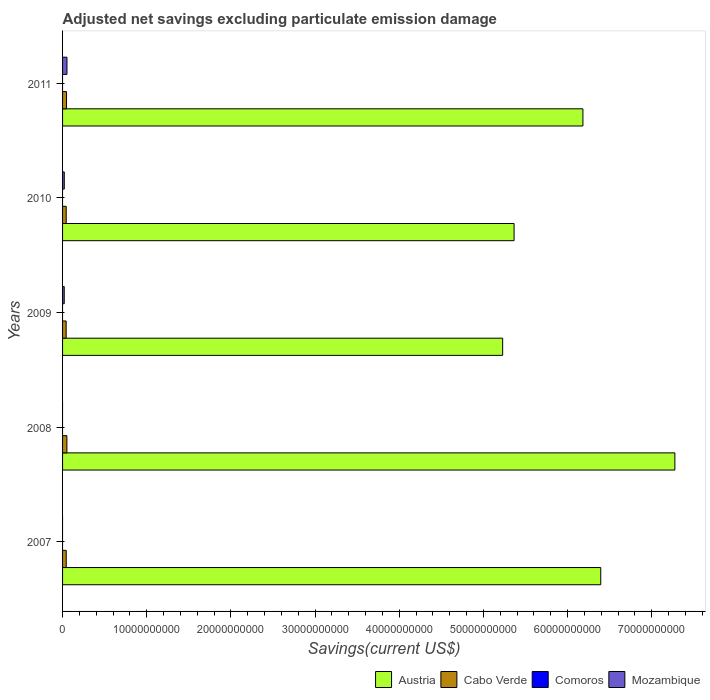How many different coloured bars are there?
Provide a succinct answer. 3. How many groups of bars are there?
Ensure brevity in your answer.  5. How many bars are there on the 4th tick from the top?
Your answer should be compact. 2. How many bars are there on the 1st tick from the bottom?
Provide a succinct answer. 2. What is the label of the 5th group of bars from the top?
Offer a very short reply. 2007. In how many cases, is the number of bars for a given year not equal to the number of legend labels?
Keep it short and to the point. 5. What is the adjusted net savings in Austria in 2007?
Keep it short and to the point. 6.39e+1. Across all years, what is the maximum adjusted net savings in Austria?
Make the answer very short. 7.27e+1. Across all years, what is the minimum adjusted net savings in Austria?
Your answer should be compact. 5.23e+1. What is the difference between the adjusted net savings in Cabo Verde in 2007 and that in 2011?
Offer a very short reply. -3.84e+07. What is the difference between the adjusted net savings in Mozambique in 2010 and the adjusted net savings in Austria in 2007?
Ensure brevity in your answer.  -6.37e+1. What is the average adjusted net savings in Comoros per year?
Give a very brief answer. 0. In the year 2008, what is the difference between the adjusted net savings in Cabo Verde and adjusted net savings in Austria?
Keep it short and to the point. -7.22e+1. What is the ratio of the adjusted net savings in Austria in 2008 to that in 2010?
Your response must be concise. 1.36. Is the adjusted net savings in Austria in 2008 less than that in 2009?
Provide a short and direct response. No. What is the difference between the highest and the second highest adjusted net savings in Cabo Verde?
Offer a very short reply. 4.26e+07. What is the difference between the highest and the lowest adjusted net savings in Cabo Verde?
Your answer should be very brief. 8.87e+07. Is it the case that in every year, the sum of the adjusted net savings in Comoros and adjusted net savings in Mozambique is greater than the sum of adjusted net savings in Austria and adjusted net savings in Cabo Verde?
Your answer should be compact. No. Is it the case that in every year, the sum of the adjusted net savings in Mozambique and adjusted net savings in Cabo Verde is greater than the adjusted net savings in Austria?
Give a very brief answer. No. Are all the bars in the graph horizontal?
Provide a succinct answer. Yes. How many years are there in the graph?
Make the answer very short. 5. Does the graph contain any zero values?
Your answer should be very brief. Yes. How many legend labels are there?
Provide a succinct answer. 4. What is the title of the graph?
Ensure brevity in your answer.  Adjusted net savings excluding particulate emission damage. Does "Tuvalu" appear as one of the legend labels in the graph?
Keep it short and to the point. No. What is the label or title of the X-axis?
Your answer should be very brief. Savings(current US$). What is the Savings(current US$) of Austria in 2007?
Provide a short and direct response. 6.39e+1. What is the Savings(current US$) in Cabo Verde in 2007?
Your answer should be compact. 4.34e+08. What is the Savings(current US$) of Comoros in 2007?
Provide a short and direct response. 0. What is the Savings(current US$) of Mozambique in 2007?
Your response must be concise. 0. What is the Savings(current US$) in Austria in 2008?
Ensure brevity in your answer.  7.27e+1. What is the Savings(current US$) of Cabo Verde in 2008?
Ensure brevity in your answer.  5.15e+08. What is the Savings(current US$) in Comoros in 2008?
Your answer should be compact. 0. What is the Savings(current US$) of Austria in 2009?
Provide a succinct answer. 5.23e+1. What is the Savings(current US$) in Cabo Verde in 2009?
Your answer should be very brief. 4.26e+08. What is the Savings(current US$) of Comoros in 2009?
Your answer should be compact. 0. What is the Savings(current US$) of Mozambique in 2009?
Your response must be concise. 1.98e+08. What is the Savings(current US$) of Austria in 2010?
Offer a very short reply. 5.36e+1. What is the Savings(current US$) in Cabo Verde in 2010?
Your response must be concise. 4.32e+08. What is the Savings(current US$) in Mozambique in 2010?
Your response must be concise. 2.04e+08. What is the Savings(current US$) in Austria in 2011?
Provide a succinct answer. 6.18e+1. What is the Savings(current US$) in Cabo Verde in 2011?
Offer a very short reply. 4.72e+08. What is the Savings(current US$) in Mozambique in 2011?
Give a very brief answer. 5.23e+08. Across all years, what is the maximum Savings(current US$) of Austria?
Your response must be concise. 7.27e+1. Across all years, what is the maximum Savings(current US$) of Cabo Verde?
Your answer should be compact. 5.15e+08. Across all years, what is the maximum Savings(current US$) in Mozambique?
Provide a short and direct response. 5.23e+08. Across all years, what is the minimum Savings(current US$) of Austria?
Provide a short and direct response. 5.23e+1. Across all years, what is the minimum Savings(current US$) of Cabo Verde?
Make the answer very short. 4.26e+08. What is the total Savings(current US$) of Austria in the graph?
Make the answer very short. 3.04e+11. What is the total Savings(current US$) of Cabo Verde in the graph?
Ensure brevity in your answer.  2.28e+09. What is the total Savings(current US$) in Mozambique in the graph?
Make the answer very short. 9.25e+08. What is the difference between the Savings(current US$) in Austria in 2007 and that in 2008?
Provide a succinct answer. -8.81e+09. What is the difference between the Savings(current US$) of Cabo Verde in 2007 and that in 2008?
Your answer should be very brief. -8.10e+07. What is the difference between the Savings(current US$) in Austria in 2007 and that in 2009?
Offer a terse response. 1.17e+1. What is the difference between the Savings(current US$) of Cabo Verde in 2007 and that in 2009?
Provide a succinct answer. 7.78e+06. What is the difference between the Savings(current US$) of Austria in 2007 and that in 2010?
Make the answer very short. 1.03e+1. What is the difference between the Savings(current US$) of Cabo Verde in 2007 and that in 2010?
Your answer should be very brief. 1.15e+06. What is the difference between the Savings(current US$) in Austria in 2007 and that in 2011?
Offer a terse response. 2.12e+09. What is the difference between the Savings(current US$) of Cabo Verde in 2007 and that in 2011?
Keep it short and to the point. -3.84e+07. What is the difference between the Savings(current US$) in Austria in 2008 and that in 2009?
Make the answer very short. 2.05e+1. What is the difference between the Savings(current US$) of Cabo Verde in 2008 and that in 2009?
Your answer should be very brief. 8.87e+07. What is the difference between the Savings(current US$) in Austria in 2008 and that in 2010?
Offer a very short reply. 1.91e+1. What is the difference between the Savings(current US$) of Cabo Verde in 2008 and that in 2010?
Offer a terse response. 8.21e+07. What is the difference between the Savings(current US$) of Austria in 2008 and that in 2011?
Provide a short and direct response. 1.09e+1. What is the difference between the Savings(current US$) in Cabo Verde in 2008 and that in 2011?
Offer a terse response. 4.26e+07. What is the difference between the Savings(current US$) of Austria in 2009 and that in 2010?
Offer a terse response. -1.36e+09. What is the difference between the Savings(current US$) of Cabo Verde in 2009 and that in 2010?
Give a very brief answer. -6.63e+06. What is the difference between the Savings(current US$) in Mozambique in 2009 and that in 2010?
Offer a very short reply. -6.49e+06. What is the difference between the Savings(current US$) of Austria in 2009 and that in 2011?
Provide a short and direct response. -9.54e+09. What is the difference between the Savings(current US$) of Cabo Verde in 2009 and that in 2011?
Your response must be concise. -4.61e+07. What is the difference between the Savings(current US$) of Mozambique in 2009 and that in 2011?
Your answer should be very brief. -3.26e+08. What is the difference between the Savings(current US$) of Austria in 2010 and that in 2011?
Offer a very short reply. -8.18e+09. What is the difference between the Savings(current US$) of Cabo Verde in 2010 and that in 2011?
Keep it short and to the point. -3.95e+07. What is the difference between the Savings(current US$) in Mozambique in 2010 and that in 2011?
Offer a very short reply. -3.19e+08. What is the difference between the Savings(current US$) in Austria in 2007 and the Savings(current US$) in Cabo Verde in 2008?
Ensure brevity in your answer.  6.34e+1. What is the difference between the Savings(current US$) of Austria in 2007 and the Savings(current US$) of Cabo Verde in 2009?
Keep it short and to the point. 6.35e+1. What is the difference between the Savings(current US$) in Austria in 2007 and the Savings(current US$) in Mozambique in 2009?
Provide a short and direct response. 6.37e+1. What is the difference between the Savings(current US$) in Cabo Verde in 2007 and the Savings(current US$) in Mozambique in 2009?
Your answer should be very brief. 2.36e+08. What is the difference between the Savings(current US$) in Austria in 2007 and the Savings(current US$) in Cabo Verde in 2010?
Provide a short and direct response. 6.35e+1. What is the difference between the Savings(current US$) in Austria in 2007 and the Savings(current US$) in Mozambique in 2010?
Your answer should be very brief. 6.37e+1. What is the difference between the Savings(current US$) in Cabo Verde in 2007 and the Savings(current US$) in Mozambique in 2010?
Provide a succinct answer. 2.29e+08. What is the difference between the Savings(current US$) of Austria in 2007 and the Savings(current US$) of Cabo Verde in 2011?
Keep it short and to the point. 6.35e+1. What is the difference between the Savings(current US$) in Austria in 2007 and the Savings(current US$) in Mozambique in 2011?
Provide a short and direct response. 6.34e+1. What is the difference between the Savings(current US$) of Cabo Verde in 2007 and the Savings(current US$) of Mozambique in 2011?
Your answer should be very brief. -8.98e+07. What is the difference between the Savings(current US$) of Austria in 2008 and the Savings(current US$) of Cabo Verde in 2009?
Your answer should be compact. 7.23e+1. What is the difference between the Savings(current US$) of Austria in 2008 and the Savings(current US$) of Mozambique in 2009?
Offer a terse response. 7.25e+1. What is the difference between the Savings(current US$) in Cabo Verde in 2008 and the Savings(current US$) in Mozambique in 2009?
Your answer should be compact. 3.17e+08. What is the difference between the Savings(current US$) in Austria in 2008 and the Savings(current US$) in Cabo Verde in 2010?
Your answer should be very brief. 7.23e+1. What is the difference between the Savings(current US$) of Austria in 2008 and the Savings(current US$) of Mozambique in 2010?
Ensure brevity in your answer.  7.25e+1. What is the difference between the Savings(current US$) in Cabo Verde in 2008 and the Savings(current US$) in Mozambique in 2010?
Offer a very short reply. 3.10e+08. What is the difference between the Savings(current US$) in Austria in 2008 and the Savings(current US$) in Cabo Verde in 2011?
Make the answer very short. 7.23e+1. What is the difference between the Savings(current US$) in Austria in 2008 and the Savings(current US$) in Mozambique in 2011?
Offer a terse response. 7.22e+1. What is the difference between the Savings(current US$) of Cabo Verde in 2008 and the Savings(current US$) of Mozambique in 2011?
Provide a succinct answer. -8.83e+06. What is the difference between the Savings(current US$) of Austria in 2009 and the Savings(current US$) of Cabo Verde in 2010?
Keep it short and to the point. 5.19e+1. What is the difference between the Savings(current US$) in Austria in 2009 and the Savings(current US$) in Mozambique in 2010?
Your response must be concise. 5.21e+1. What is the difference between the Savings(current US$) in Cabo Verde in 2009 and the Savings(current US$) in Mozambique in 2010?
Keep it short and to the point. 2.22e+08. What is the difference between the Savings(current US$) in Austria in 2009 and the Savings(current US$) in Cabo Verde in 2011?
Provide a succinct answer. 5.18e+1. What is the difference between the Savings(current US$) in Austria in 2009 and the Savings(current US$) in Mozambique in 2011?
Provide a short and direct response. 5.18e+1. What is the difference between the Savings(current US$) of Cabo Verde in 2009 and the Savings(current US$) of Mozambique in 2011?
Provide a short and direct response. -9.76e+07. What is the difference between the Savings(current US$) in Austria in 2010 and the Savings(current US$) in Cabo Verde in 2011?
Give a very brief answer. 5.32e+1. What is the difference between the Savings(current US$) in Austria in 2010 and the Savings(current US$) in Mozambique in 2011?
Provide a succinct answer. 5.31e+1. What is the difference between the Savings(current US$) in Cabo Verde in 2010 and the Savings(current US$) in Mozambique in 2011?
Offer a very short reply. -9.09e+07. What is the average Savings(current US$) in Austria per year?
Offer a very short reply. 6.09e+1. What is the average Savings(current US$) in Cabo Verde per year?
Provide a succinct answer. 4.56e+08. What is the average Savings(current US$) of Comoros per year?
Your answer should be compact. 0. What is the average Savings(current US$) in Mozambique per year?
Provide a succinct answer. 1.85e+08. In the year 2007, what is the difference between the Savings(current US$) in Austria and Savings(current US$) in Cabo Verde?
Offer a terse response. 6.35e+1. In the year 2008, what is the difference between the Savings(current US$) in Austria and Savings(current US$) in Cabo Verde?
Offer a terse response. 7.22e+1. In the year 2009, what is the difference between the Savings(current US$) of Austria and Savings(current US$) of Cabo Verde?
Your response must be concise. 5.19e+1. In the year 2009, what is the difference between the Savings(current US$) of Austria and Savings(current US$) of Mozambique?
Offer a very short reply. 5.21e+1. In the year 2009, what is the difference between the Savings(current US$) in Cabo Verde and Savings(current US$) in Mozambique?
Your answer should be very brief. 2.28e+08. In the year 2010, what is the difference between the Savings(current US$) in Austria and Savings(current US$) in Cabo Verde?
Your answer should be compact. 5.32e+1. In the year 2010, what is the difference between the Savings(current US$) in Austria and Savings(current US$) in Mozambique?
Make the answer very short. 5.34e+1. In the year 2010, what is the difference between the Savings(current US$) of Cabo Verde and Savings(current US$) of Mozambique?
Your answer should be very brief. 2.28e+08. In the year 2011, what is the difference between the Savings(current US$) in Austria and Savings(current US$) in Cabo Verde?
Your answer should be compact. 6.14e+1. In the year 2011, what is the difference between the Savings(current US$) of Austria and Savings(current US$) of Mozambique?
Offer a very short reply. 6.13e+1. In the year 2011, what is the difference between the Savings(current US$) in Cabo Verde and Savings(current US$) in Mozambique?
Keep it short and to the point. -5.14e+07. What is the ratio of the Savings(current US$) of Austria in 2007 to that in 2008?
Provide a short and direct response. 0.88. What is the ratio of the Savings(current US$) of Cabo Verde in 2007 to that in 2008?
Provide a short and direct response. 0.84. What is the ratio of the Savings(current US$) of Austria in 2007 to that in 2009?
Make the answer very short. 1.22. What is the ratio of the Savings(current US$) in Cabo Verde in 2007 to that in 2009?
Provide a succinct answer. 1.02. What is the ratio of the Savings(current US$) in Austria in 2007 to that in 2010?
Your answer should be very brief. 1.19. What is the ratio of the Savings(current US$) in Cabo Verde in 2007 to that in 2010?
Keep it short and to the point. 1. What is the ratio of the Savings(current US$) of Austria in 2007 to that in 2011?
Provide a succinct answer. 1.03. What is the ratio of the Savings(current US$) of Cabo Verde in 2007 to that in 2011?
Make the answer very short. 0.92. What is the ratio of the Savings(current US$) of Austria in 2008 to that in 2009?
Give a very brief answer. 1.39. What is the ratio of the Savings(current US$) in Cabo Verde in 2008 to that in 2009?
Ensure brevity in your answer.  1.21. What is the ratio of the Savings(current US$) of Austria in 2008 to that in 2010?
Provide a succinct answer. 1.36. What is the ratio of the Savings(current US$) of Cabo Verde in 2008 to that in 2010?
Your answer should be compact. 1.19. What is the ratio of the Savings(current US$) of Austria in 2008 to that in 2011?
Offer a terse response. 1.18. What is the ratio of the Savings(current US$) in Cabo Verde in 2008 to that in 2011?
Keep it short and to the point. 1.09. What is the ratio of the Savings(current US$) of Austria in 2009 to that in 2010?
Provide a short and direct response. 0.97. What is the ratio of the Savings(current US$) in Cabo Verde in 2009 to that in 2010?
Offer a very short reply. 0.98. What is the ratio of the Savings(current US$) of Mozambique in 2009 to that in 2010?
Offer a very short reply. 0.97. What is the ratio of the Savings(current US$) of Austria in 2009 to that in 2011?
Your response must be concise. 0.85. What is the ratio of the Savings(current US$) of Cabo Verde in 2009 to that in 2011?
Make the answer very short. 0.9. What is the ratio of the Savings(current US$) of Mozambique in 2009 to that in 2011?
Offer a terse response. 0.38. What is the ratio of the Savings(current US$) of Austria in 2010 to that in 2011?
Your answer should be very brief. 0.87. What is the ratio of the Savings(current US$) in Cabo Verde in 2010 to that in 2011?
Give a very brief answer. 0.92. What is the ratio of the Savings(current US$) of Mozambique in 2010 to that in 2011?
Provide a short and direct response. 0.39. What is the difference between the highest and the second highest Savings(current US$) in Austria?
Ensure brevity in your answer.  8.81e+09. What is the difference between the highest and the second highest Savings(current US$) in Cabo Verde?
Provide a short and direct response. 4.26e+07. What is the difference between the highest and the second highest Savings(current US$) of Mozambique?
Make the answer very short. 3.19e+08. What is the difference between the highest and the lowest Savings(current US$) in Austria?
Your answer should be very brief. 2.05e+1. What is the difference between the highest and the lowest Savings(current US$) of Cabo Verde?
Your response must be concise. 8.87e+07. What is the difference between the highest and the lowest Savings(current US$) in Mozambique?
Provide a succinct answer. 5.23e+08. 